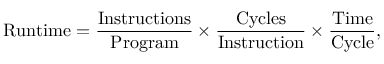Convert formula to latex. <formula><loc_0><loc_0><loc_500><loc_500>R u n t i m e = { \frac { I n s t r u c t i o n s } { P r o g r a m } } \times { \frac { C y c l e s } { I n s t r u c t i o n } } \times { \frac { T i m e } { C y c l e } } ,</formula> 